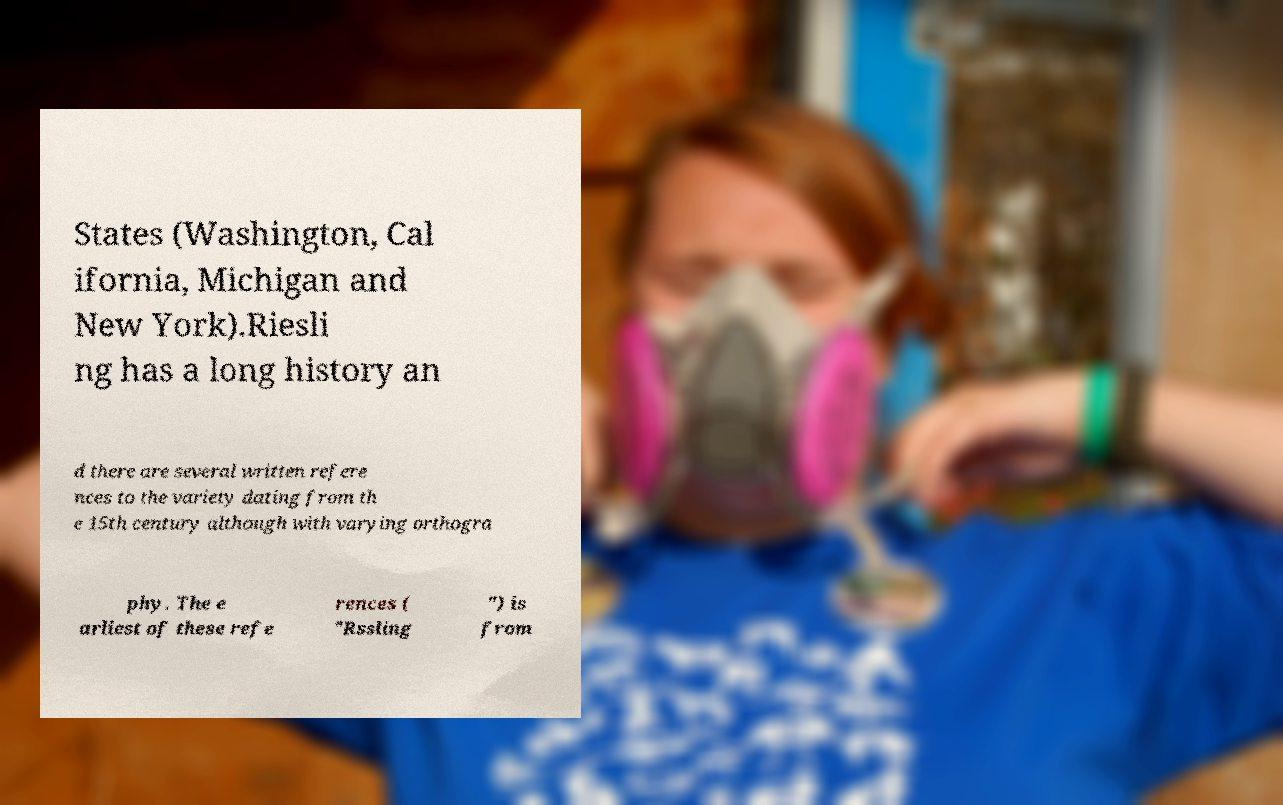What messages or text are displayed in this image? I need them in a readable, typed format. States (Washington, Cal ifornia, Michigan and New York).Riesli ng has a long history an d there are several written refere nces to the variety dating from th e 15th century although with varying orthogra phy. The e arliest of these refe rences ( "Rssling ") is from 